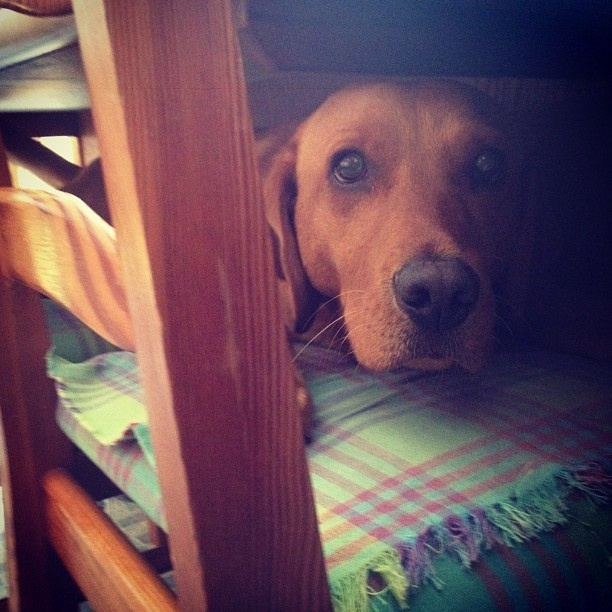Describe the objects in this image and their specific colors. I can see chair in brown, purple, black, and gray tones, bed in brown, black, gray, navy, and darkgray tones, and dog in brown, navy, and purple tones in this image. 